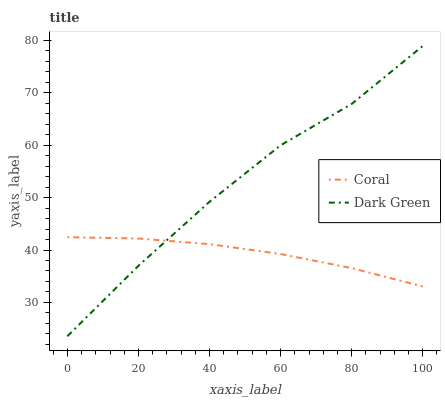Does Coral have the minimum area under the curve?
Answer yes or no. Yes. Does Dark Green have the maximum area under the curve?
Answer yes or no. Yes. Does Dark Green have the minimum area under the curve?
Answer yes or no. No. Is Coral the smoothest?
Answer yes or no. Yes. Is Dark Green the roughest?
Answer yes or no. Yes. Is Dark Green the smoothest?
Answer yes or no. No. Does Dark Green have the highest value?
Answer yes or no. Yes. 